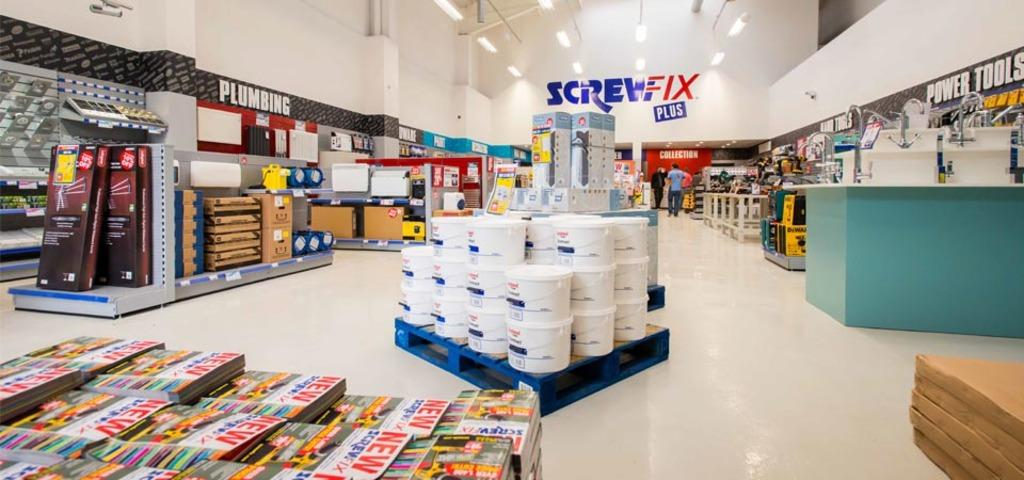Provide a one-sentence caption for the provided image. A hardware store with signs for Screwfix, plumbing and power tools. 